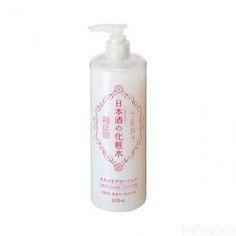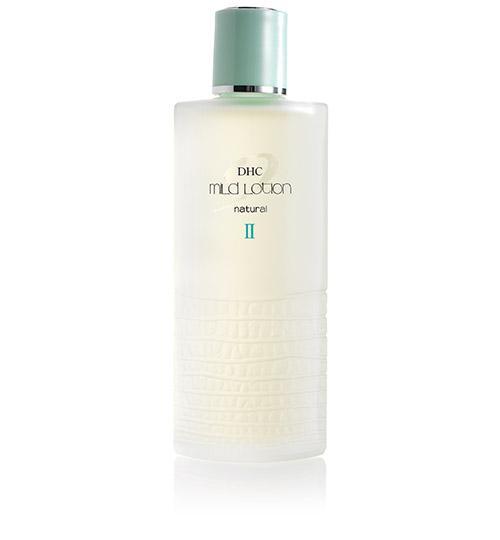The first image is the image on the left, the second image is the image on the right. Analyze the images presented: Is the assertion "The product on the left is in a pump-top bottle with its nozzle turned leftward, and the product on the right does not have a pump-top." valid? Answer yes or no. Yes. The first image is the image on the left, the second image is the image on the right. Analyze the images presented: Is the assertion "The container in the image on the left has a pump nozzle." valid? Answer yes or no. Yes. 